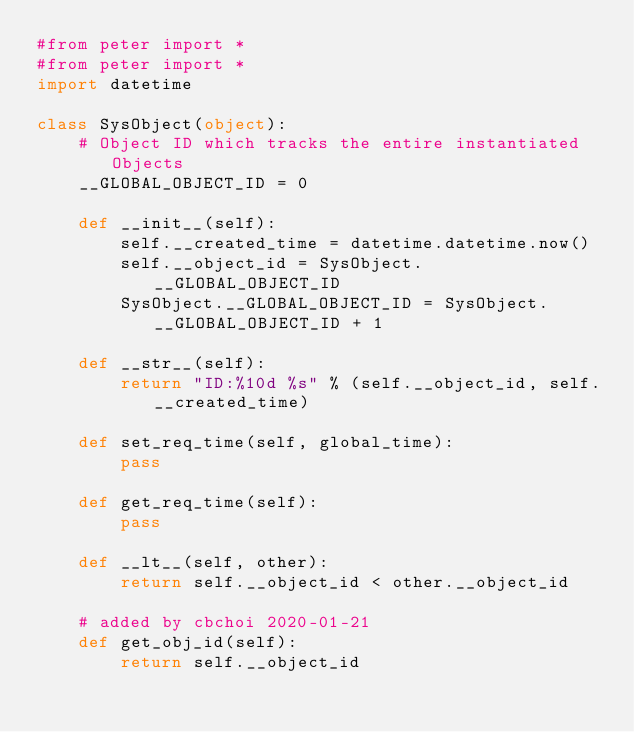Convert code to text. <code><loc_0><loc_0><loc_500><loc_500><_Python_>#from peter import *
#from peter import *
import datetime

class SysObject(object):
    # Object ID which tracks the entire instantiated Objects
    __GLOBAL_OBJECT_ID = 0

    def __init__(self):
        self.__created_time = datetime.datetime.now()
        self.__object_id = SysObject.__GLOBAL_OBJECT_ID
        SysObject.__GLOBAL_OBJECT_ID = SysObject.__GLOBAL_OBJECT_ID + 1

    def __str__(self):
        return "ID:%10d %s" % (self.__object_id, self.__created_time)

    def set_req_time(self, global_time):
        pass

    def get_req_time(self):
        pass

    def __lt__(self, other):
        return self.__object_id < other.__object_id

    # added by cbchoi 2020-01-21
    def get_obj_id(self):
        return self.__object_id</code> 